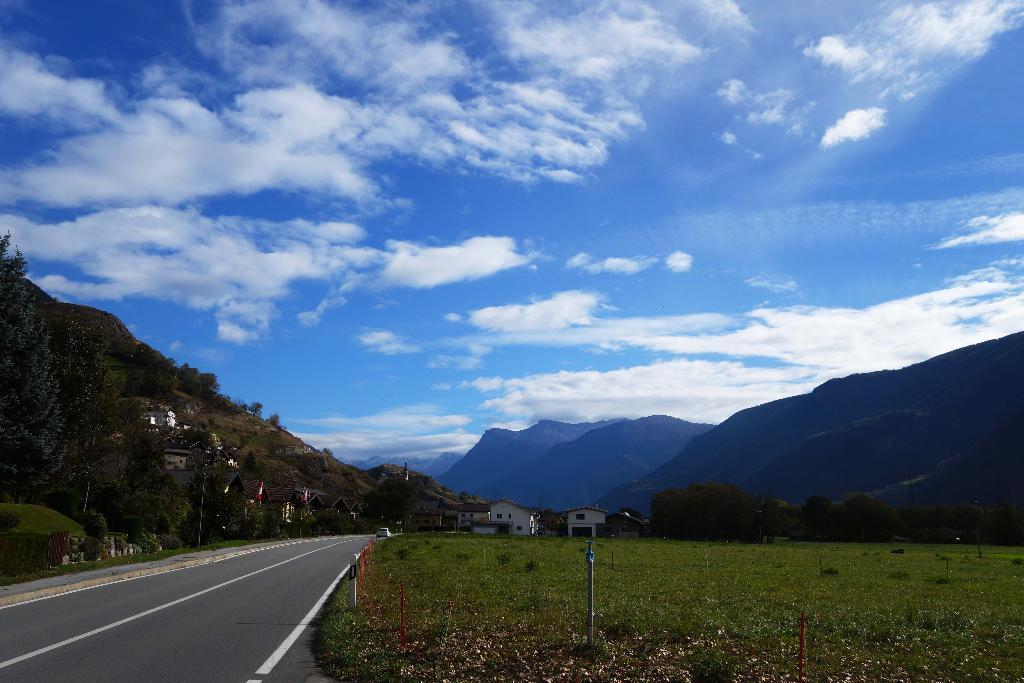What is the main feature of the image? There is a road in the image. What can be seen alongside the road? There is fencing in the image. What type of terrain is visible near the road? There is grassy land in the image. What structures can be seen in the distance? There are houses in the background of the image. What natural features are visible in the background? There are mountains and trees in the background of the image. How would you describe the sky in the image? The sky is blue with clouds. What type of pickle is being used to decorate the fencing in the image? There is no pickle present in the image; it is a road with fencing, grassy land, houses, mountains, trees, and a blue sky with clouds. 